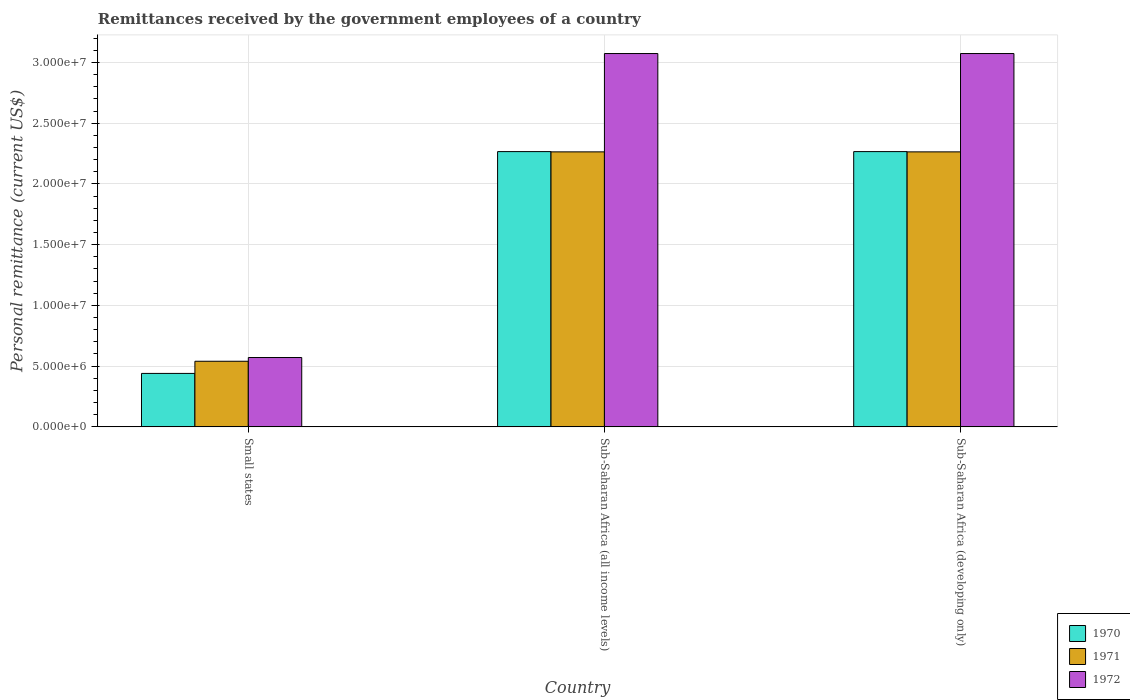How many groups of bars are there?
Ensure brevity in your answer.  3. How many bars are there on the 3rd tick from the left?
Offer a very short reply. 3. What is the label of the 1st group of bars from the left?
Offer a terse response. Small states. In how many cases, is the number of bars for a given country not equal to the number of legend labels?
Your answer should be compact. 0. What is the remittances received by the government employees in 1971 in Sub-Saharan Africa (all income levels)?
Keep it short and to the point. 2.26e+07. Across all countries, what is the maximum remittances received by the government employees in 1971?
Provide a succinct answer. 2.26e+07. Across all countries, what is the minimum remittances received by the government employees in 1970?
Make the answer very short. 4.40e+06. In which country was the remittances received by the government employees in 1970 maximum?
Provide a short and direct response. Sub-Saharan Africa (all income levels). In which country was the remittances received by the government employees in 1972 minimum?
Keep it short and to the point. Small states. What is the total remittances received by the government employees in 1972 in the graph?
Your response must be concise. 6.72e+07. What is the difference between the remittances received by the government employees in 1971 in Small states and that in Sub-Saharan Africa (all income levels)?
Your answer should be very brief. -1.72e+07. What is the difference between the remittances received by the government employees in 1971 in Sub-Saharan Africa (all income levels) and the remittances received by the government employees in 1970 in Small states?
Your response must be concise. 1.82e+07. What is the average remittances received by the government employees in 1972 per country?
Make the answer very short. 2.24e+07. What is the difference between the remittances received by the government employees of/in 1972 and remittances received by the government employees of/in 1970 in Sub-Saharan Africa (all income levels)?
Your answer should be very brief. 8.07e+06. In how many countries, is the remittances received by the government employees in 1972 greater than 8000000 US$?
Your response must be concise. 2. What is the ratio of the remittances received by the government employees in 1972 in Small states to that in Sub-Saharan Africa (all income levels)?
Make the answer very short. 0.19. Is the difference between the remittances received by the government employees in 1972 in Small states and Sub-Saharan Africa (all income levels) greater than the difference between the remittances received by the government employees in 1970 in Small states and Sub-Saharan Africa (all income levels)?
Your answer should be very brief. No. What is the difference between the highest and the second highest remittances received by the government employees in 1971?
Keep it short and to the point. 1.72e+07. What is the difference between the highest and the lowest remittances received by the government employees in 1971?
Ensure brevity in your answer.  1.72e+07. Is the sum of the remittances received by the government employees in 1972 in Small states and Sub-Saharan Africa (all income levels) greater than the maximum remittances received by the government employees in 1970 across all countries?
Your answer should be very brief. Yes. What does the 3rd bar from the right in Sub-Saharan Africa (developing only) represents?
Your answer should be very brief. 1970. Is it the case that in every country, the sum of the remittances received by the government employees in 1972 and remittances received by the government employees in 1971 is greater than the remittances received by the government employees in 1970?
Keep it short and to the point. Yes. How many bars are there?
Your answer should be compact. 9. Are all the bars in the graph horizontal?
Your answer should be very brief. No. What is the difference between two consecutive major ticks on the Y-axis?
Offer a terse response. 5.00e+06. Are the values on the major ticks of Y-axis written in scientific E-notation?
Your response must be concise. Yes. Does the graph contain any zero values?
Make the answer very short. No. Does the graph contain grids?
Your response must be concise. Yes. Where does the legend appear in the graph?
Provide a short and direct response. Bottom right. What is the title of the graph?
Keep it short and to the point. Remittances received by the government employees of a country. Does "1988" appear as one of the legend labels in the graph?
Make the answer very short. No. What is the label or title of the Y-axis?
Provide a succinct answer. Personal remittance (current US$). What is the Personal remittance (current US$) in 1970 in Small states?
Your response must be concise. 4.40e+06. What is the Personal remittance (current US$) in 1971 in Small states?
Your answer should be compact. 5.40e+06. What is the Personal remittance (current US$) of 1972 in Small states?
Your response must be concise. 5.71e+06. What is the Personal remittance (current US$) in 1970 in Sub-Saharan Africa (all income levels)?
Your answer should be very brief. 2.27e+07. What is the Personal remittance (current US$) of 1971 in Sub-Saharan Africa (all income levels)?
Offer a terse response. 2.26e+07. What is the Personal remittance (current US$) of 1972 in Sub-Saharan Africa (all income levels)?
Provide a short and direct response. 3.07e+07. What is the Personal remittance (current US$) in 1970 in Sub-Saharan Africa (developing only)?
Provide a short and direct response. 2.27e+07. What is the Personal remittance (current US$) in 1971 in Sub-Saharan Africa (developing only)?
Your response must be concise. 2.26e+07. What is the Personal remittance (current US$) of 1972 in Sub-Saharan Africa (developing only)?
Offer a very short reply. 3.07e+07. Across all countries, what is the maximum Personal remittance (current US$) in 1970?
Ensure brevity in your answer.  2.27e+07. Across all countries, what is the maximum Personal remittance (current US$) of 1971?
Give a very brief answer. 2.26e+07. Across all countries, what is the maximum Personal remittance (current US$) of 1972?
Provide a succinct answer. 3.07e+07. Across all countries, what is the minimum Personal remittance (current US$) in 1970?
Keep it short and to the point. 4.40e+06. Across all countries, what is the minimum Personal remittance (current US$) in 1971?
Your response must be concise. 5.40e+06. Across all countries, what is the minimum Personal remittance (current US$) of 1972?
Give a very brief answer. 5.71e+06. What is the total Personal remittance (current US$) in 1970 in the graph?
Provide a short and direct response. 4.97e+07. What is the total Personal remittance (current US$) in 1971 in the graph?
Make the answer very short. 5.07e+07. What is the total Personal remittance (current US$) in 1972 in the graph?
Offer a terse response. 6.72e+07. What is the difference between the Personal remittance (current US$) of 1970 in Small states and that in Sub-Saharan Africa (all income levels)?
Ensure brevity in your answer.  -1.83e+07. What is the difference between the Personal remittance (current US$) in 1971 in Small states and that in Sub-Saharan Africa (all income levels)?
Keep it short and to the point. -1.72e+07. What is the difference between the Personal remittance (current US$) in 1972 in Small states and that in Sub-Saharan Africa (all income levels)?
Provide a succinct answer. -2.50e+07. What is the difference between the Personal remittance (current US$) in 1970 in Small states and that in Sub-Saharan Africa (developing only)?
Your answer should be very brief. -1.83e+07. What is the difference between the Personal remittance (current US$) of 1971 in Small states and that in Sub-Saharan Africa (developing only)?
Your answer should be very brief. -1.72e+07. What is the difference between the Personal remittance (current US$) of 1972 in Small states and that in Sub-Saharan Africa (developing only)?
Ensure brevity in your answer.  -2.50e+07. What is the difference between the Personal remittance (current US$) in 1971 in Sub-Saharan Africa (all income levels) and that in Sub-Saharan Africa (developing only)?
Your answer should be very brief. 0. What is the difference between the Personal remittance (current US$) in 1970 in Small states and the Personal remittance (current US$) in 1971 in Sub-Saharan Africa (all income levels)?
Keep it short and to the point. -1.82e+07. What is the difference between the Personal remittance (current US$) in 1970 in Small states and the Personal remittance (current US$) in 1972 in Sub-Saharan Africa (all income levels)?
Give a very brief answer. -2.63e+07. What is the difference between the Personal remittance (current US$) in 1971 in Small states and the Personal remittance (current US$) in 1972 in Sub-Saharan Africa (all income levels)?
Give a very brief answer. -2.53e+07. What is the difference between the Personal remittance (current US$) in 1970 in Small states and the Personal remittance (current US$) in 1971 in Sub-Saharan Africa (developing only)?
Your answer should be very brief. -1.82e+07. What is the difference between the Personal remittance (current US$) in 1970 in Small states and the Personal remittance (current US$) in 1972 in Sub-Saharan Africa (developing only)?
Provide a succinct answer. -2.63e+07. What is the difference between the Personal remittance (current US$) of 1971 in Small states and the Personal remittance (current US$) of 1972 in Sub-Saharan Africa (developing only)?
Provide a short and direct response. -2.53e+07. What is the difference between the Personal remittance (current US$) of 1970 in Sub-Saharan Africa (all income levels) and the Personal remittance (current US$) of 1971 in Sub-Saharan Africa (developing only)?
Your response must be concise. 2.18e+04. What is the difference between the Personal remittance (current US$) of 1970 in Sub-Saharan Africa (all income levels) and the Personal remittance (current US$) of 1972 in Sub-Saharan Africa (developing only)?
Keep it short and to the point. -8.07e+06. What is the difference between the Personal remittance (current US$) of 1971 in Sub-Saharan Africa (all income levels) and the Personal remittance (current US$) of 1972 in Sub-Saharan Africa (developing only)?
Your response must be concise. -8.09e+06. What is the average Personal remittance (current US$) in 1970 per country?
Give a very brief answer. 1.66e+07. What is the average Personal remittance (current US$) of 1971 per country?
Offer a terse response. 1.69e+07. What is the average Personal remittance (current US$) in 1972 per country?
Provide a short and direct response. 2.24e+07. What is the difference between the Personal remittance (current US$) of 1970 and Personal remittance (current US$) of 1971 in Small states?
Offer a terse response. -1.00e+06. What is the difference between the Personal remittance (current US$) of 1970 and Personal remittance (current US$) of 1972 in Small states?
Your answer should be compact. -1.31e+06. What is the difference between the Personal remittance (current US$) in 1971 and Personal remittance (current US$) in 1972 in Small states?
Offer a very short reply. -3.07e+05. What is the difference between the Personal remittance (current US$) in 1970 and Personal remittance (current US$) in 1971 in Sub-Saharan Africa (all income levels)?
Provide a succinct answer. 2.18e+04. What is the difference between the Personal remittance (current US$) of 1970 and Personal remittance (current US$) of 1972 in Sub-Saharan Africa (all income levels)?
Your answer should be very brief. -8.07e+06. What is the difference between the Personal remittance (current US$) of 1971 and Personal remittance (current US$) of 1972 in Sub-Saharan Africa (all income levels)?
Give a very brief answer. -8.09e+06. What is the difference between the Personal remittance (current US$) in 1970 and Personal remittance (current US$) in 1971 in Sub-Saharan Africa (developing only)?
Provide a short and direct response. 2.18e+04. What is the difference between the Personal remittance (current US$) of 1970 and Personal remittance (current US$) of 1972 in Sub-Saharan Africa (developing only)?
Offer a very short reply. -8.07e+06. What is the difference between the Personal remittance (current US$) in 1971 and Personal remittance (current US$) in 1972 in Sub-Saharan Africa (developing only)?
Your answer should be very brief. -8.09e+06. What is the ratio of the Personal remittance (current US$) of 1970 in Small states to that in Sub-Saharan Africa (all income levels)?
Keep it short and to the point. 0.19. What is the ratio of the Personal remittance (current US$) in 1971 in Small states to that in Sub-Saharan Africa (all income levels)?
Keep it short and to the point. 0.24. What is the ratio of the Personal remittance (current US$) of 1972 in Small states to that in Sub-Saharan Africa (all income levels)?
Give a very brief answer. 0.19. What is the ratio of the Personal remittance (current US$) in 1970 in Small states to that in Sub-Saharan Africa (developing only)?
Keep it short and to the point. 0.19. What is the ratio of the Personal remittance (current US$) of 1971 in Small states to that in Sub-Saharan Africa (developing only)?
Your response must be concise. 0.24. What is the ratio of the Personal remittance (current US$) in 1972 in Small states to that in Sub-Saharan Africa (developing only)?
Your answer should be very brief. 0.19. What is the ratio of the Personal remittance (current US$) in 1970 in Sub-Saharan Africa (all income levels) to that in Sub-Saharan Africa (developing only)?
Your response must be concise. 1. What is the ratio of the Personal remittance (current US$) in 1971 in Sub-Saharan Africa (all income levels) to that in Sub-Saharan Africa (developing only)?
Make the answer very short. 1. What is the difference between the highest and the second highest Personal remittance (current US$) of 1970?
Provide a short and direct response. 0. What is the difference between the highest and the second highest Personal remittance (current US$) in 1972?
Provide a short and direct response. 0. What is the difference between the highest and the lowest Personal remittance (current US$) of 1970?
Offer a very short reply. 1.83e+07. What is the difference between the highest and the lowest Personal remittance (current US$) of 1971?
Your response must be concise. 1.72e+07. What is the difference between the highest and the lowest Personal remittance (current US$) in 1972?
Provide a short and direct response. 2.50e+07. 